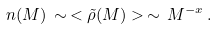Convert formula to latex. <formula><loc_0><loc_0><loc_500><loc_500>n ( M ) \, \sim \, < { \tilde { \rho } } ( M ) > \, \sim \, M ^ { - x } \, .</formula> 